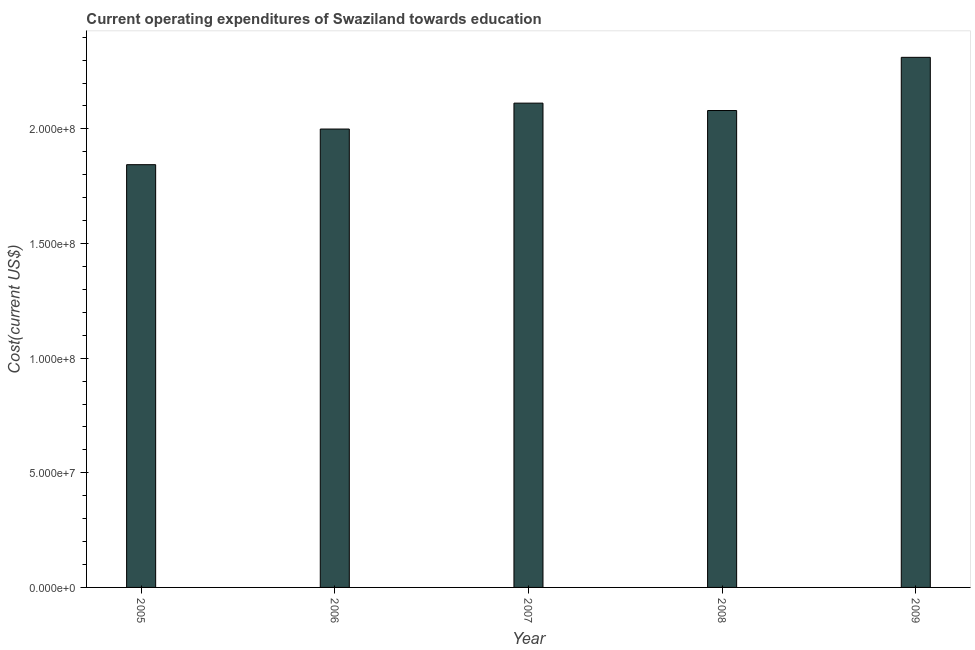Does the graph contain grids?
Your answer should be very brief. No. What is the title of the graph?
Give a very brief answer. Current operating expenditures of Swaziland towards education. What is the label or title of the Y-axis?
Your response must be concise. Cost(current US$). What is the education expenditure in 2009?
Give a very brief answer. 2.31e+08. Across all years, what is the maximum education expenditure?
Keep it short and to the point. 2.31e+08. Across all years, what is the minimum education expenditure?
Provide a short and direct response. 1.84e+08. In which year was the education expenditure minimum?
Ensure brevity in your answer.  2005. What is the sum of the education expenditure?
Provide a succinct answer. 1.03e+09. What is the difference between the education expenditure in 2005 and 2009?
Your answer should be very brief. -4.68e+07. What is the average education expenditure per year?
Your response must be concise. 2.07e+08. What is the median education expenditure?
Make the answer very short. 2.08e+08. What is the ratio of the education expenditure in 2005 to that in 2007?
Your answer should be very brief. 0.87. Is the difference between the education expenditure in 2008 and 2009 greater than the difference between any two years?
Make the answer very short. No. What is the difference between the highest and the second highest education expenditure?
Ensure brevity in your answer.  2.00e+07. What is the difference between the highest and the lowest education expenditure?
Your answer should be compact. 4.68e+07. In how many years, is the education expenditure greater than the average education expenditure taken over all years?
Your answer should be compact. 3. Are all the bars in the graph horizontal?
Your response must be concise. No. What is the difference between two consecutive major ticks on the Y-axis?
Offer a terse response. 5.00e+07. Are the values on the major ticks of Y-axis written in scientific E-notation?
Provide a succinct answer. Yes. What is the Cost(current US$) in 2005?
Provide a succinct answer. 1.84e+08. What is the Cost(current US$) in 2006?
Offer a very short reply. 2.00e+08. What is the Cost(current US$) of 2007?
Provide a succinct answer. 2.11e+08. What is the Cost(current US$) in 2008?
Offer a terse response. 2.08e+08. What is the Cost(current US$) of 2009?
Your response must be concise. 2.31e+08. What is the difference between the Cost(current US$) in 2005 and 2006?
Your response must be concise. -1.55e+07. What is the difference between the Cost(current US$) in 2005 and 2007?
Give a very brief answer. -2.68e+07. What is the difference between the Cost(current US$) in 2005 and 2008?
Your answer should be compact. -2.36e+07. What is the difference between the Cost(current US$) in 2005 and 2009?
Offer a very short reply. -4.68e+07. What is the difference between the Cost(current US$) in 2006 and 2007?
Provide a short and direct response. -1.13e+07. What is the difference between the Cost(current US$) in 2006 and 2008?
Your answer should be compact. -8.08e+06. What is the difference between the Cost(current US$) in 2006 and 2009?
Provide a short and direct response. -3.13e+07. What is the difference between the Cost(current US$) in 2007 and 2008?
Provide a short and direct response. 3.22e+06. What is the difference between the Cost(current US$) in 2007 and 2009?
Your response must be concise. -2.00e+07. What is the difference between the Cost(current US$) in 2008 and 2009?
Your answer should be compact. -2.32e+07. What is the ratio of the Cost(current US$) in 2005 to that in 2006?
Your response must be concise. 0.92. What is the ratio of the Cost(current US$) in 2005 to that in 2007?
Keep it short and to the point. 0.87. What is the ratio of the Cost(current US$) in 2005 to that in 2008?
Offer a very short reply. 0.89. What is the ratio of the Cost(current US$) in 2005 to that in 2009?
Your response must be concise. 0.8. What is the ratio of the Cost(current US$) in 2006 to that in 2007?
Give a very brief answer. 0.95. What is the ratio of the Cost(current US$) in 2006 to that in 2009?
Your response must be concise. 0.86. What is the ratio of the Cost(current US$) in 2007 to that in 2009?
Provide a succinct answer. 0.91. What is the ratio of the Cost(current US$) in 2008 to that in 2009?
Provide a succinct answer. 0.9. 